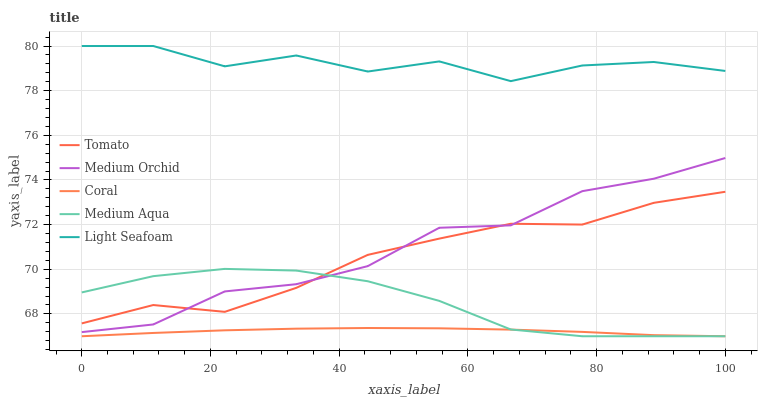Does Coral have the minimum area under the curve?
Answer yes or no. Yes. Does Light Seafoam have the maximum area under the curve?
Answer yes or no. Yes. Does Medium Orchid have the minimum area under the curve?
Answer yes or no. No. Does Medium Orchid have the maximum area under the curve?
Answer yes or no. No. Is Coral the smoothest?
Answer yes or no. Yes. Is Light Seafoam the roughest?
Answer yes or no. Yes. Is Medium Orchid the smoothest?
Answer yes or no. No. Is Medium Orchid the roughest?
Answer yes or no. No. Does Coral have the lowest value?
Answer yes or no. Yes. Does Medium Orchid have the lowest value?
Answer yes or no. No. Does Light Seafoam have the highest value?
Answer yes or no. Yes. Does Medium Orchid have the highest value?
Answer yes or no. No. Is Coral less than Tomato?
Answer yes or no. Yes. Is Light Seafoam greater than Tomato?
Answer yes or no. Yes. Does Medium Aqua intersect Coral?
Answer yes or no. Yes. Is Medium Aqua less than Coral?
Answer yes or no. No. Is Medium Aqua greater than Coral?
Answer yes or no. No. Does Coral intersect Tomato?
Answer yes or no. No. 